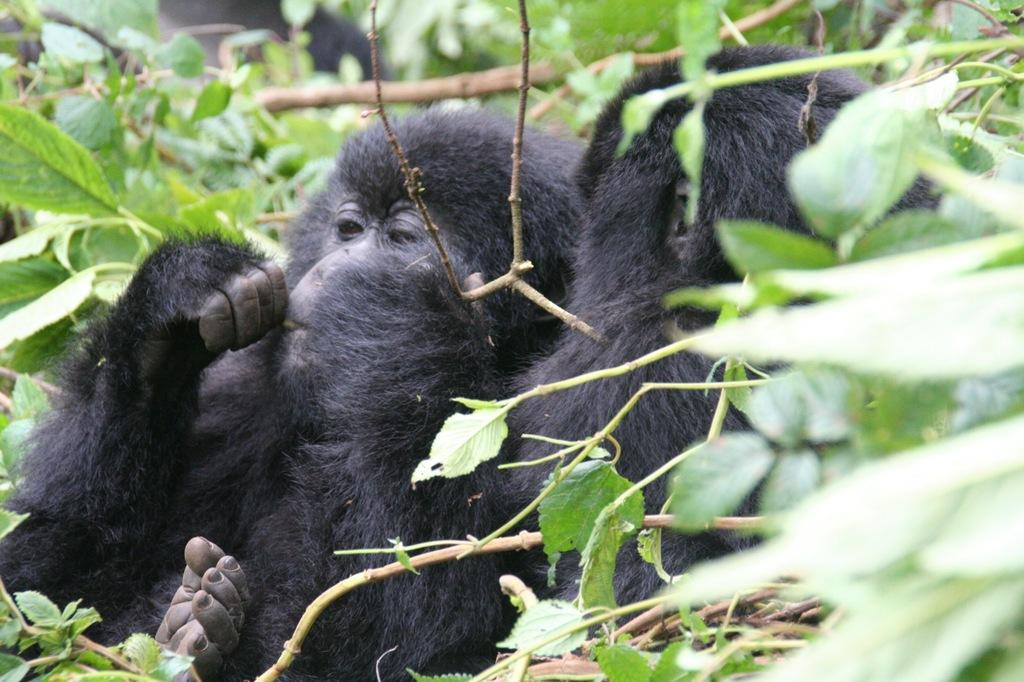What animals are present in the image? There are two black monkeys in the image. Where are the monkeys located in the image? The monkeys are in the middle of the image. What type of vegetation is visible in the image? There are plants with green leaves in the image. What type of snow can be seen on the ground in the image? There is no snow present in the image; it features two black monkeys and plants with green leaves. How many feet are visible in the image? There are no feet visible in the image. 